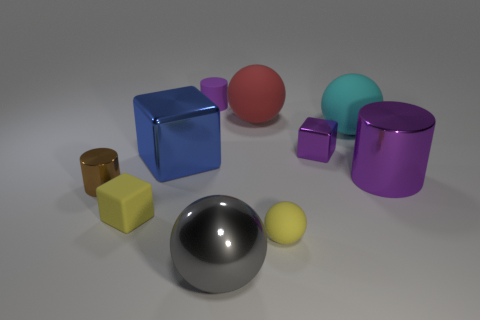How does the lighting in the image affect the appearance of the objects? The lighting in the image creates soft shadows and subtle reflections, enhancing the objects' three-dimensional qualities and highlighting their textures—metallic surfaces reflect light more sharply, while matte surfaces absorb light and have softer reflections. 